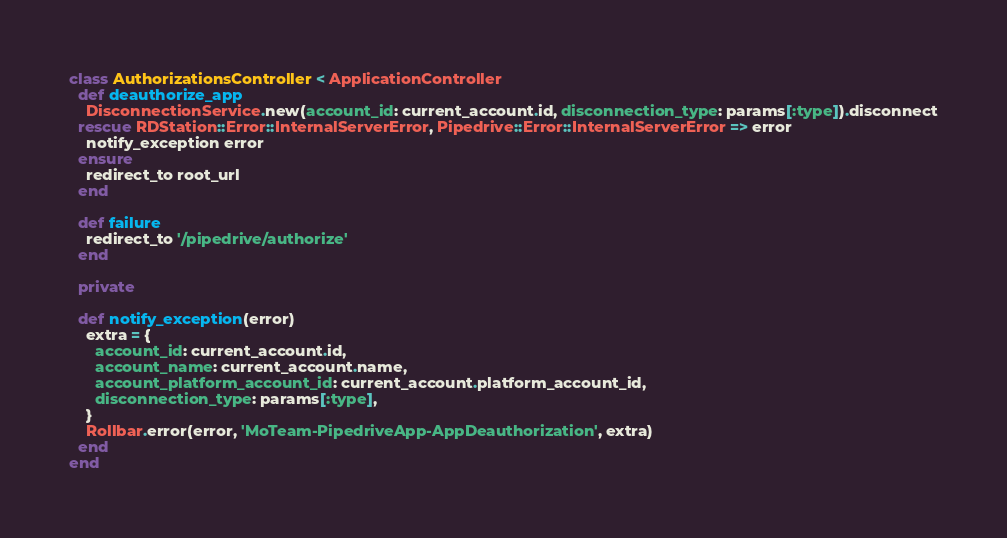<code> <loc_0><loc_0><loc_500><loc_500><_Ruby_>class AuthorizationsController < ApplicationController
  def deauthorize_app
    DisconnectionService.new(account_id: current_account.id, disconnection_type: params[:type]).disconnect
  rescue RDStation::Error::InternalServerError, Pipedrive::Error::InternalServerError => error
    notify_exception error
  ensure
    redirect_to root_url
  end

  def failure
    redirect_to '/pipedrive/authorize'
  end

  private

  def notify_exception(error)
    extra = {
      account_id: current_account.id,
      account_name: current_account.name,
      account_platform_account_id: current_account.platform_account_id,
      disconnection_type: params[:type],
    }
    Rollbar.error(error, 'MoTeam-PipedriveApp-AppDeauthorization', extra)
  end
end
</code> 